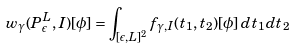Convert formula to latex. <formula><loc_0><loc_0><loc_500><loc_500>w _ { \gamma } ( P _ { \epsilon } ^ { L } , I ) [ \phi ] = \int _ { [ \epsilon , L ] ^ { 2 } } f _ { \gamma , I } ( t _ { 1 } , t _ { 2 } ) [ \phi ] \, d t _ { 1 } d t _ { 2 }</formula> 